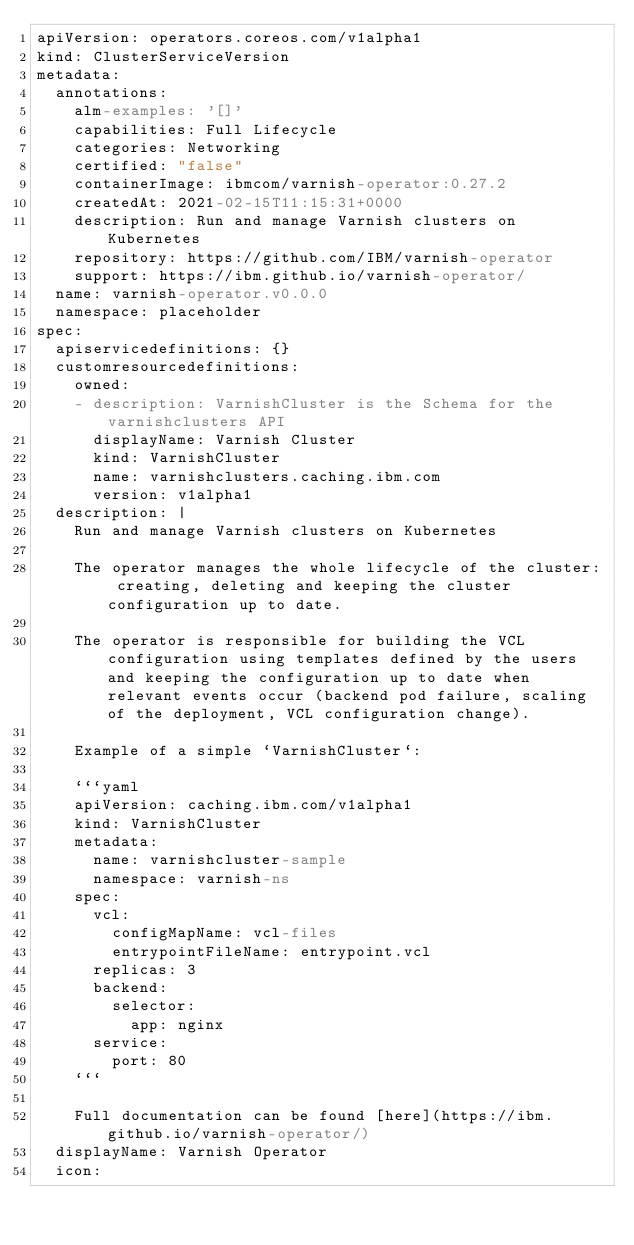Convert code to text. <code><loc_0><loc_0><loc_500><loc_500><_YAML_>apiVersion: operators.coreos.com/v1alpha1
kind: ClusterServiceVersion
metadata:
  annotations:
    alm-examples: '[]'
    capabilities: Full Lifecycle
    categories: Networking
    certified: "false"
    containerImage: ibmcom/varnish-operator:0.27.2
    createdAt: 2021-02-15T11:15:31+0000
    description: Run and manage Varnish clusters on Kubernetes
    repository: https://github.com/IBM/varnish-operator
    support: https://ibm.github.io/varnish-operator/
  name: varnish-operator.v0.0.0
  namespace: placeholder
spec:
  apiservicedefinitions: {}
  customresourcedefinitions:
    owned:
    - description: VarnishCluster is the Schema for the varnishclusters API
      displayName: Varnish Cluster
      kind: VarnishCluster
      name: varnishclusters.caching.ibm.com
      version: v1alpha1
  description: |
    Run and manage Varnish clusters on Kubernetes

    The operator manages the whole lifecycle of the cluster: creating, deleting and keeping the cluster configuration up to date.

    The operator is responsible for building the VCL configuration using templates defined by the users and keeping the configuration up to date when relevant events occur (backend pod failure, scaling of the deployment, VCL configuration change).

    Example of a simple `VarnishCluster`:

    ```yaml
    apiVersion: caching.ibm.com/v1alpha1
    kind: VarnishCluster
    metadata:
      name: varnishcluster-sample
      namespace: varnish-ns
    spec:
      vcl:
        configMapName: vcl-files
        entrypointFileName: entrypoint.vcl
      replicas: 3
      backend:
        selector:
          app: nginx
      service:
        port: 80
    ```

    Full documentation can be found [here](https://ibm.github.io/varnish-operator/)
  displayName: Varnish Operator
  icon:</code> 